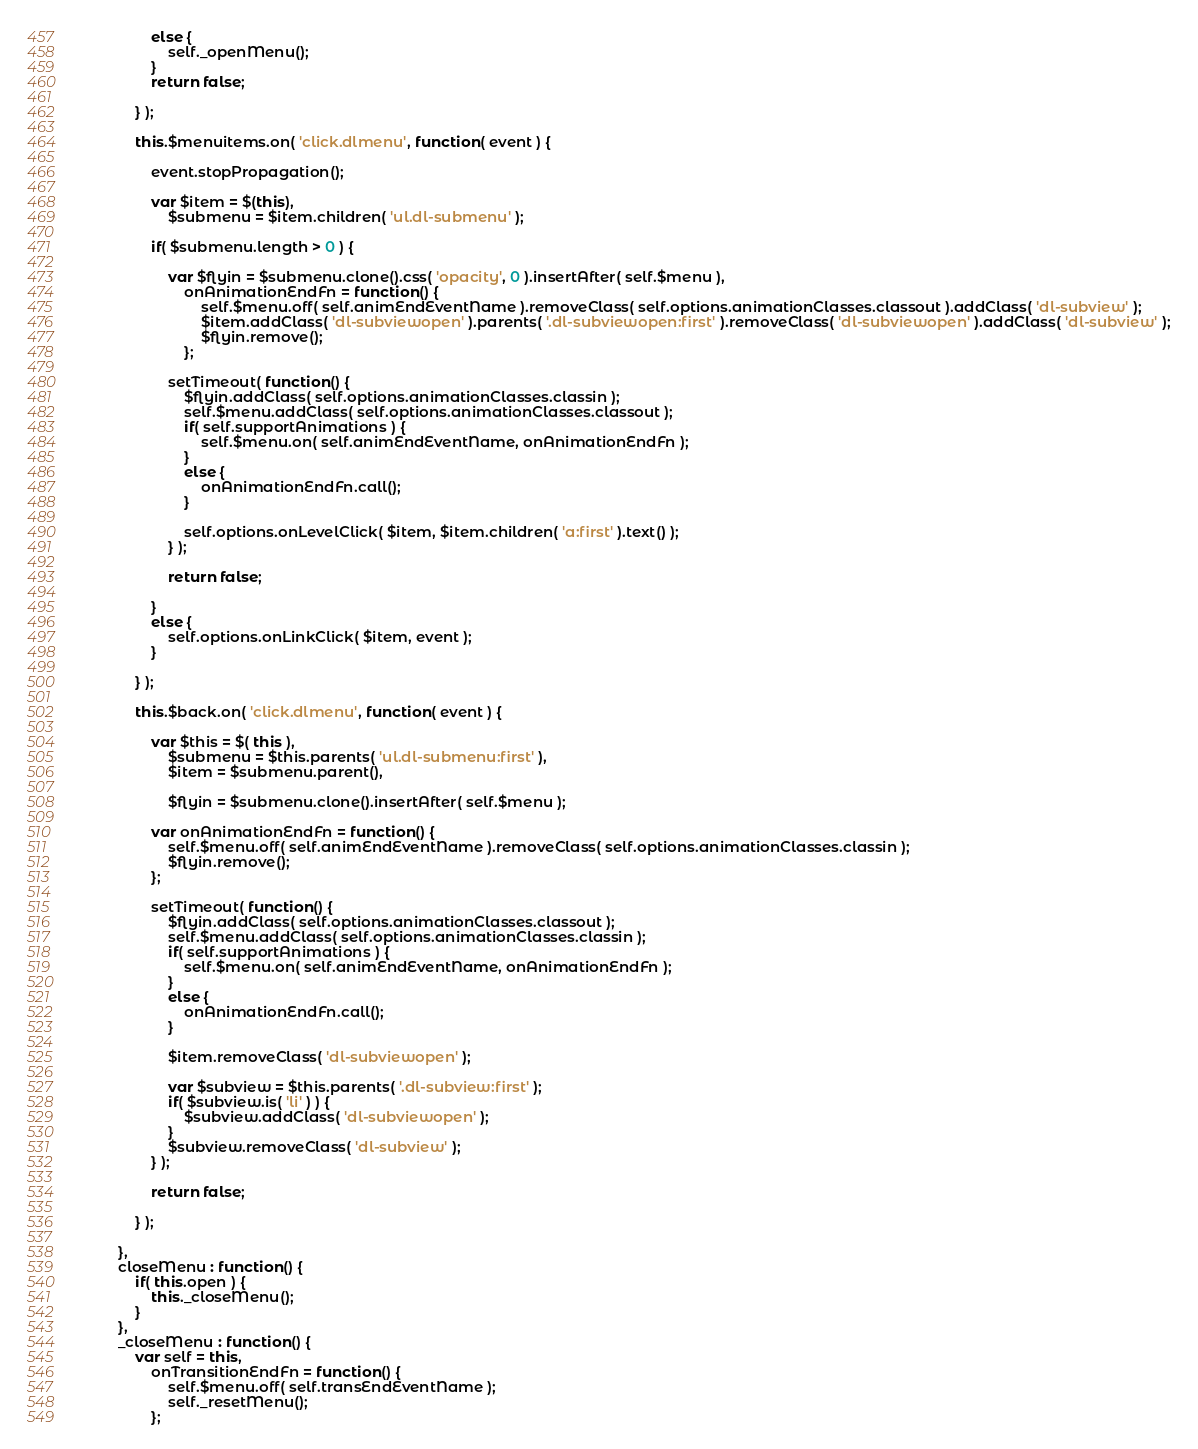Convert code to text. <code><loc_0><loc_0><loc_500><loc_500><_JavaScript_>				else {
					self._openMenu();
				}
				return false;

			} );

			this.$menuitems.on( 'click.dlmenu', function( event ) {
				
				event.stopPropagation();

				var $item = $(this),
					$submenu = $item.children( 'ul.dl-submenu' );

				if( $submenu.length > 0 ) {

					var $flyin = $submenu.clone().css( 'opacity', 0 ).insertAfter( self.$menu ),
						onAnimationEndFn = function() {
							self.$menu.off( self.animEndEventName ).removeClass( self.options.animationClasses.classout ).addClass( 'dl-subview' );
							$item.addClass( 'dl-subviewopen' ).parents( '.dl-subviewopen:first' ).removeClass( 'dl-subviewopen' ).addClass( 'dl-subview' );
							$flyin.remove();
						};

					setTimeout( function() {
						$flyin.addClass( self.options.animationClasses.classin );
						self.$menu.addClass( self.options.animationClasses.classout );
						if( self.supportAnimations ) {
							self.$menu.on( self.animEndEventName, onAnimationEndFn );
						}
						else {
							onAnimationEndFn.call();
						}

						self.options.onLevelClick( $item, $item.children( 'a:first' ).text() );
					} );

					return false;

				}
				else {
					self.options.onLinkClick( $item, event );
				}

			} );

			this.$back.on( 'click.dlmenu', function( event ) {
				
				var $this = $( this ),
					$submenu = $this.parents( 'ul.dl-submenu:first' ),
					$item = $submenu.parent(),

					$flyin = $submenu.clone().insertAfter( self.$menu );

				var onAnimationEndFn = function() {
					self.$menu.off( self.animEndEventName ).removeClass( self.options.animationClasses.classin );
					$flyin.remove();
				};

				setTimeout( function() {
					$flyin.addClass( self.options.animationClasses.classout );
					self.$menu.addClass( self.options.animationClasses.classin );
					if( self.supportAnimations ) {
						self.$menu.on( self.animEndEventName, onAnimationEndFn );
					}
					else {
						onAnimationEndFn.call();
					}

					$item.removeClass( 'dl-subviewopen' );
					
					var $subview = $this.parents( '.dl-subview:first' );
					if( $subview.is( 'li' ) ) {
						$subview.addClass( 'dl-subviewopen' );
					}
					$subview.removeClass( 'dl-subview' );
				} );

				return false;

			} );
			
		},
		closeMenu : function() {
			if( this.open ) {
				this._closeMenu();
			}
		},
		_closeMenu : function() {
			var self = this,
				onTransitionEndFn = function() {
					self.$menu.off( self.transEndEventName );
					self._resetMenu();
				};</code> 